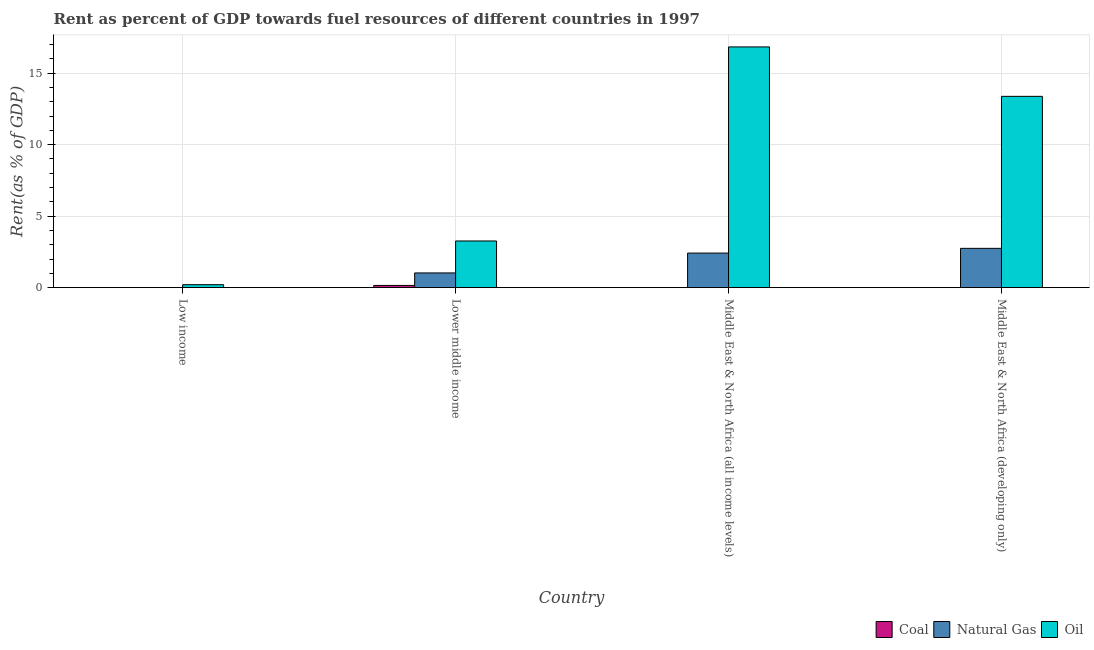How many different coloured bars are there?
Make the answer very short. 3. How many groups of bars are there?
Provide a succinct answer. 4. Are the number of bars on each tick of the X-axis equal?
Your answer should be very brief. Yes. How many bars are there on the 4th tick from the left?
Provide a short and direct response. 3. How many bars are there on the 4th tick from the right?
Your response must be concise. 3. What is the label of the 4th group of bars from the left?
Provide a short and direct response. Middle East & North Africa (developing only). What is the rent towards coal in Lower middle income?
Your answer should be compact. 0.16. Across all countries, what is the maximum rent towards natural gas?
Offer a very short reply. 2.75. Across all countries, what is the minimum rent towards natural gas?
Make the answer very short. 3.83841350463664e-5. In which country was the rent towards coal maximum?
Provide a succinct answer. Lower middle income. What is the total rent towards oil in the graph?
Give a very brief answer. 33.68. What is the difference between the rent towards oil in Middle East & North Africa (all income levels) and that in Middle East & North Africa (developing only)?
Give a very brief answer. 3.46. What is the difference between the rent towards coal in Low income and the rent towards oil in Middle East & North Africa (developing only)?
Your answer should be very brief. -13.37. What is the average rent towards oil per country?
Provide a succinct answer. 8.42. What is the difference between the rent towards natural gas and rent towards oil in Middle East & North Africa (developing only)?
Ensure brevity in your answer.  -10.63. What is the ratio of the rent towards natural gas in Middle East & North Africa (all income levels) to that in Middle East & North Africa (developing only)?
Your response must be concise. 0.88. What is the difference between the highest and the second highest rent towards coal?
Offer a very short reply. 0.15. What is the difference between the highest and the lowest rent towards oil?
Your answer should be very brief. 16.62. What does the 1st bar from the left in Lower middle income represents?
Your response must be concise. Coal. What does the 3rd bar from the right in Middle East & North Africa (all income levels) represents?
Your response must be concise. Coal. Is it the case that in every country, the sum of the rent towards coal and rent towards natural gas is greater than the rent towards oil?
Your answer should be very brief. No. Are all the bars in the graph horizontal?
Your answer should be compact. No. Where does the legend appear in the graph?
Make the answer very short. Bottom right. What is the title of the graph?
Offer a very short reply. Rent as percent of GDP towards fuel resources of different countries in 1997. What is the label or title of the X-axis?
Make the answer very short. Country. What is the label or title of the Y-axis?
Your answer should be compact. Rent(as % of GDP). What is the Rent(as % of GDP) of Coal in Low income?
Offer a terse response. 0. What is the Rent(as % of GDP) in Natural Gas in Low income?
Keep it short and to the point. 3.83841350463664e-5. What is the Rent(as % of GDP) in Oil in Low income?
Keep it short and to the point. 0.21. What is the Rent(as % of GDP) of Coal in Lower middle income?
Make the answer very short. 0.16. What is the Rent(as % of GDP) of Natural Gas in Lower middle income?
Your response must be concise. 1.03. What is the Rent(as % of GDP) in Oil in Lower middle income?
Keep it short and to the point. 3.26. What is the Rent(as % of GDP) of Coal in Middle East & North Africa (all income levels)?
Offer a terse response. 0. What is the Rent(as % of GDP) in Natural Gas in Middle East & North Africa (all income levels)?
Your answer should be compact. 2.42. What is the Rent(as % of GDP) of Oil in Middle East & North Africa (all income levels)?
Make the answer very short. 16.83. What is the Rent(as % of GDP) in Coal in Middle East & North Africa (developing only)?
Ensure brevity in your answer.  0. What is the Rent(as % of GDP) of Natural Gas in Middle East & North Africa (developing only)?
Ensure brevity in your answer.  2.75. What is the Rent(as % of GDP) of Oil in Middle East & North Africa (developing only)?
Offer a very short reply. 13.37. Across all countries, what is the maximum Rent(as % of GDP) in Coal?
Give a very brief answer. 0.16. Across all countries, what is the maximum Rent(as % of GDP) in Natural Gas?
Provide a short and direct response. 2.75. Across all countries, what is the maximum Rent(as % of GDP) in Oil?
Provide a succinct answer. 16.83. Across all countries, what is the minimum Rent(as % of GDP) in Coal?
Your answer should be compact. 0. Across all countries, what is the minimum Rent(as % of GDP) of Natural Gas?
Keep it short and to the point. 3.83841350463664e-5. Across all countries, what is the minimum Rent(as % of GDP) of Oil?
Make the answer very short. 0.21. What is the total Rent(as % of GDP) of Coal in the graph?
Offer a very short reply. 0.16. What is the total Rent(as % of GDP) in Natural Gas in the graph?
Provide a succinct answer. 6.2. What is the total Rent(as % of GDP) in Oil in the graph?
Give a very brief answer. 33.68. What is the difference between the Rent(as % of GDP) of Coal in Low income and that in Lower middle income?
Provide a succinct answer. -0.16. What is the difference between the Rent(as % of GDP) of Natural Gas in Low income and that in Lower middle income?
Offer a very short reply. -1.03. What is the difference between the Rent(as % of GDP) in Oil in Low income and that in Lower middle income?
Ensure brevity in your answer.  -3.06. What is the difference between the Rent(as % of GDP) of Coal in Low income and that in Middle East & North Africa (all income levels)?
Provide a succinct answer. -0. What is the difference between the Rent(as % of GDP) in Natural Gas in Low income and that in Middle East & North Africa (all income levels)?
Your answer should be compact. -2.42. What is the difference between the Rent(as % of GDP) of Oil in Low income and that in Middle East & North Africa (all income levels)?
Make the answer very short. -16.62. What is the difference between the Rent(as % of GDP) in Coal in Low income and that in Middle East & North Africa (developing only)?
Provide a succinct answer. -0. What is the difference between the Rent(as % of GDP) of Natural Gas in Low income and that in Middle East & North Africa (developing only)?
Your response must be concise. -2.75. What is the difference between the Rent(as % of GDP) in Oil in Low income and that in Middle East & North Africa (developing only)?
Make the answer very short. -13.17. What is the difference between the Rent(as % of GDP) of Coal in Lower middle income and that in Middle East & North Africa (all income levels)?
Make the answer very short. 0.16. What is the difference between the Rent(as % of GDP) of Natural Gas in Lower middle income and that in Middle East & North Africa (all income levels)?
Offer a very short reply. -1.39. What is the difference between the Rent(as % of GDP) of Oil in Lower middle income and that in Middle East & North Africa (all income levels)?
Your answer should be very brief. -13.57. What is the difference between the Rent(as % of GDP) of Coal in Lower middle income and that in Middle East & North Africa (developing only)?
Provide a succinct answer. 0.15. What is the difference between the Rent(as % of GDP) in Natural Gas in Lower middle income and that in Middle East & North Africa (developing only)?
Provide a succinct answer. -1.72. What is the difference between the Rent(as % of GDP) in Oil in Lower middle income and that in Middle East & North Africa (developing only)?
Provide a short and direct response. -10.11. What is the difference between the Rent(as % of GDP) in Coal in Middle East & North Africa (all income levels) and that in Middle East & North Africa (developing only)?
Make the answer very short. -0. What is the difference between the Rent(as % of GDP) of Natural Gas in Middle East & North Africa (all income levels) and that in Middle East & North Africa (developing only)?
Provide a short and direct response. -0.33. What is the difference between the Rent(as % of GDP) of Oil in Middle East & North Africa (all income levels) and that in Middle East & North Africa (developing only)?
Give a very brief answer. 3.46. What is the difference between the Rent(as % of GDP) in Coal in Low income and the Rent(as % of GDP) in Natural Gas in Lower middle income?
Offer a very short reply. -1.03. What is the difference between the Rent(as % of GDP) in Coal in Low income and the Rent(as % of GDP) in Oil in Lower middle income?
Keep it short and to the point. -3.26. What is the difference between the Rent(as % of GDP) in Natural Gas in Low income and the Rent(as % of GDP) in Oil in Lower middle income?
Make the answer very short. -3.26. What is the difference between the Rent(as % of GDP) of Coal in Low income and the Rent(as % of GDP) of Natural Gas in Middle East & North Africa (all income levels)?
Give a very brief answer. -2.42. What is the difference between the Rent(as % of GDP) of Coal in Low income and the Rent(as % of GDP) of Oil in Middle East & North Africa (all income levels)?
Offer a terse response. -16.83. What is the difference between the Rent(as % of GDP) in Natural Gas in Low income and the Rent(as % of GDP) in Oil in Middle East & North Africa (all income levels)?
Make the answer very short. -16.83. What is the difference between the Rent(as % of GDP) in Coal in Low income and the Rent(as % of GDP) in Natural Gas in Middle East & North Africa (developing only)?
Keep it short and to the point. -2.75. What is the difference between the Rent(as % of GDP) of Coal in Low income and the Rent(as % of GDP) of Oil in Middle East & North Africa (developing only)?
Offer a terse response. -13.37. What is the difference between the Rent(as % of GDP) of Natural Gas in Low income and the Rent(as % of GDP) of Oil in Middle East & North Africa (developing only)?
Keep it short and to the point. -13.37. What is the difference between the Rent(as % of GDP) in Coal in Lower middle income and the Rent(as % of GDP) in Natural Gas in Middle East & North Africa (all income levels)?
Offer a terse response. -2.26. What is the difference between the Rent(as % of GDP) in Coal in Lower middle income and the Rent(as % of GDP) in Oil in Middle East & North Africa (all income levels)?
Your answer should be compact. -16.67. What is the difference between the Rent(as % of GDP) in Natural Gas in Lower middle income and the Rent(as % of GDP) in Oil in Middle East & North Africa (all income levels)?
Keep it short and to the point. -15.8. What is the difference between the Rent(as % of GDP) of Coal in Lower middle income and the Rent(as % of GDP) of Natural Gas in Middle East & North Africa (developing only)?
Provide a succinct answer. -2.59. What is the difference between the Rent(as % of GDP) of Coal in Lower middle income and the Rent(as % of GDP) of Oil in Middle East & North Africa (developing only)?
Provide a succinct answer. -13.22. What is the difference between the Rent(as % of GDP) in Natural Gas in Lower middle income and the Rent(as % of GDP) in Oil in Middle East & North Africa (developing only)?
Keep it short and to the point. -12.34. What is the difference between the Rent(as % of GDP) in Coal in Middle East & North Africa (all income levels) and the Rent(as % of GDP) in Natural Gas in Middle East & North Africa (developing only)?
Provide a succinct answer. -2.75. What is the difference between the Rent(as % of GDP) in Coal in Middle East & North Africa (all income levels) and the Rent(as % of GDP) in Oil in Middle East & North Africa (developing only)?
Ensure brevity in your answer.  -13.37. What is the difference between the Rent(as % of GDP) in Natural Gas in Middle East & North Africa (all income levels) and the Rent(as % of GDP) in Oil in Middle East & North Africa (developing only)?
Your answer should be compact. -10.96. What is the average Rent(as % of GDP) in Coal per country?
Your answer should be very brief. 0.04. What is the average Rent(as % of GDP) in Natural Gas per country?
Keep it short and to the point. 1.55. What is the average Rent(as % of GDP) in Oil per country?
Your answer should be very brief. 8.42. What is the difference between the Rent(as % of GDP) of Coal and Rent(as % of GDP) of Oil in Low income?
Make the answer very short. -0.21. What is the difference between the Rent(as % of GDP) of Natural Gas and Rent(as % of GDP) of Oil in Low income?
Your answer should be very brief. -0.21. What is the difference between the Rent(as % of GDP) of Coal and Rent(as % of GDP) of Natural Gas in Lower middle income?
Your answer should be compact. -0.87. What is the difference between the Rent(as % of GDP) in Coal and Rent(as % of GDP) in Oil in Lower middle income?
Make the answer very short. -3.11. What is the difference between the Rent(as % of GDP) in Natural Gas and Rent(as % of GDP) in Oil in Lower middle income?
Ensure brevity in your answer.  -2.23. What is the difference between the Rent(as % of GDP) in Coal and Rent(as % of GDP) in Natural Gas in Middle East & North Africa (all income levels)?
Your answer should be very brief. -2.42. What is the difference between the Rent(as % of GDP) in Coal and Rent(as % of GDP) in Oil in Middle East & North Africa (all income levels)?
Provide a succinct answer. -16.83. What is the difference between the Rent(as % of GDP) in Natural Gas and Rent(as % of GDP) in Oil in Middle East & North Africa (all income levels)?
Provide a short and direct response. -14.41. What is the difference between the Rent(as % of GDP) in Coal and Rent(as % of GDP) in Natural Gas in Middle East & North Africa (developing only)?
Make the answer very short. -2.75. What is the difference between the Rent(as % of GDP) in Coal and Rent(as % of GDP) in Oil in Middle East & North Africa (developing only)?
Provide a succinct answer. -13.37. What is the difference between the Rent(as % of GDP) of Natural Gas and Rent(as % of GDP) of Oil in Middle East & North Africa (developing only)?
Provide a succinct answer. -10.63. What is the ratio of the Rent(as % of GDP) of Coal in Low income to that in Lower middle income?
Your answer should be compact. 0. What is the ratio of the Rent(as % of GDP) in Natural Gas in Low income to that in Lower middle income?
Offer a very short reply. 0. What is the ratio of the Rent(as % of GDP) of Oil in Low income to that in Lower middle income?
Offer a very short reply. 0.06. What is the ratio of the Rent(as % of GDP) of Coal in Low income to that in Middle East & North Africa (all income levels)?
Offer a very short reply. 0.13. What is the ratio of the Rent(as % of GDP) in Oil in Low income to that in Middle East & North Africa (all income levels)?
Offer a very short reply. 0.01. What is the ratio of the Rent(as % of GDP) of Coal in Low income to that in Middle East & North Africa (developing only)?
Your answer should be compact. 0.06. What is the ratio of the Rent(as % of GDP) in Oil in Low income to that in Middle East & North Africa (developing only)?
Keep it short and to the point. 0.02. What is the ratio of the Rent(as % of GDP) in Coal in Lower middle income to that in Middle East & North Africa (all income levels)?
Make the answer very short. 168.66. What is the ratio of the Rent(as % of GDP) of Natural Gas in Lower middle income to that in Middle East & North Africa (all income levels)?
Offer a very short reply. 0.43. What is the ratio of the Rent(as % of GDP) of Oil in Lower middle income to that in Middle East & North Africa (all income levels)?
Make the answer very short. 0.19. What is the ratio of the Rent(as % of GDP) in Coal in Lower middle income to that in Middle East & North Africa (developing only)?
Give a very brief answer. 79.3. What is the ratio of the Rent(as % of GDP) in Oil in Lower middle income to that in Middle East & North Africa (developing only)?
Your answer should be very brief. 0.24. What is the ratio of the Rent(as % of GDP) in Coal in Middle East & North Africa (all income levels) to that in Middle East & North Africa (developing only)?
Give a very brief answer. 0.47. What is the ratio of the Rent(as % of GDP) in Natural Gas in Middle East & North Africa (all income levels) to that in Middle East & North Africa (developing only)?
Offer a very short reply. 0.88. What is the ratio of the Rent(as % of GDP) in Oil in Middle East & North Africa (all income levels) to that in Middle East & North Africa (developing only)?
Provide a succinct answer. 1.26. What is the difference between the highest and the second highest Rent(as % of GDP) in Coal?
Provide a short and direct response. 0.15. What is the difference between the highest and the second highest Rent(as % of GDP) of Natural Gas?
Make the answer very short. 0.33. What is the difference between the highest and the second highest Rent(as % of GDP) of Oil?
Provide a short and direct response. 3.46. What is the difference between the highest and the lowest Rent(as % of GDP) in Coal?
Offer a terse response. 0.16. What is the difference between the highest and the lowest Rent(as % of GDP) in Natural Gas?
Keep it short and to the point. 2.75. What is the difference between the highest and the lowest Rent(as % of GDP) of Oil?
Your answer should be compact. 16.62. 